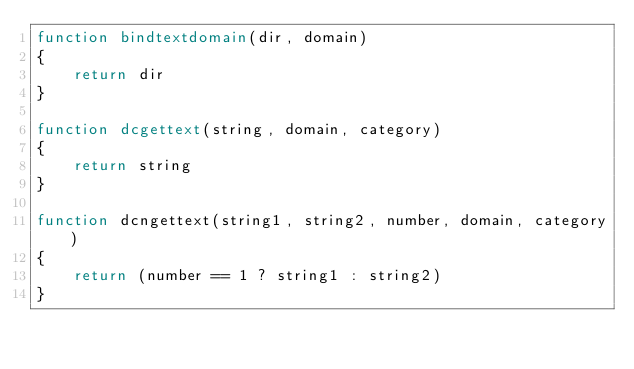Convert code to text. <code><loc_0><loc_0><loc_500><loc_500><_Awk_>function bindtextdomain(dir, domain)
{
    return dir
}

function dcgettext(string, domain, category)
{
    return string
}

function dcngettext(string1, string2, number, domain, category)
{
    return (number == 1 ? string1 : string2)
}
</code> 